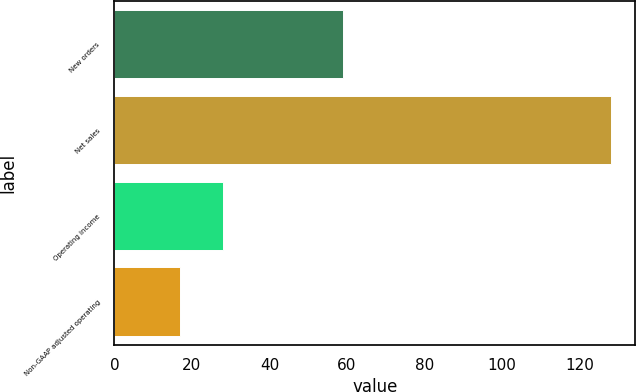Convert chart to OTSL. <chart><loc_0><loc_0><loc_500><loc_500><bar_chart><fcel>New orders<fcel>Net sales<fcel>Operating income<fcel>Non-GAAP adjusted operating<nl><fcel>59<fcel>128<fcel>28.1<fcel>17<nl></chart> 